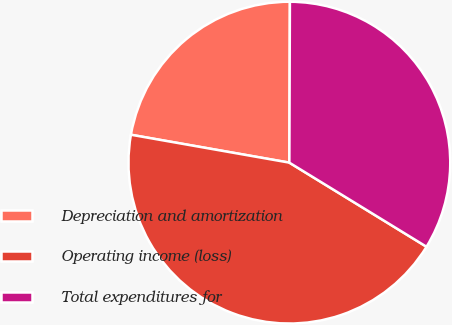<chart> <loc_0><loc_0><loc_500><loc_500><pie_chart><fcel>Depreciation and amortization<fcel>Operating income (loss)<fcel>Total expenditures for<nl><fcel>22.28%<fcel>44.02%<fcel>33.7%<nl></chart> 